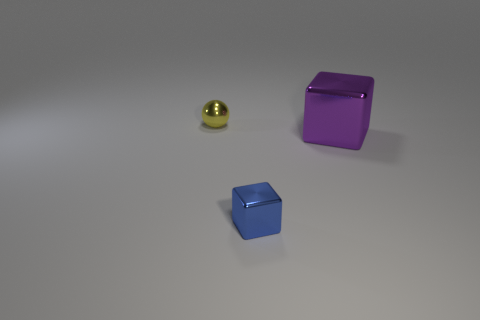Add 3 large metal objects. How many objects exist? 6 Subtract all cubes. How many objects are left? 1 Subtract all green cylinders. Subtract all tiny blue metallic cubes. How many objects are left? 2 Add 2 shiny blocks. How many shiny blocks are left? 4 Add 2 tiny yellow balls. How many tiny yellow balls exist? 3 Subtract 0 red blocks. How many objects are left? 3 